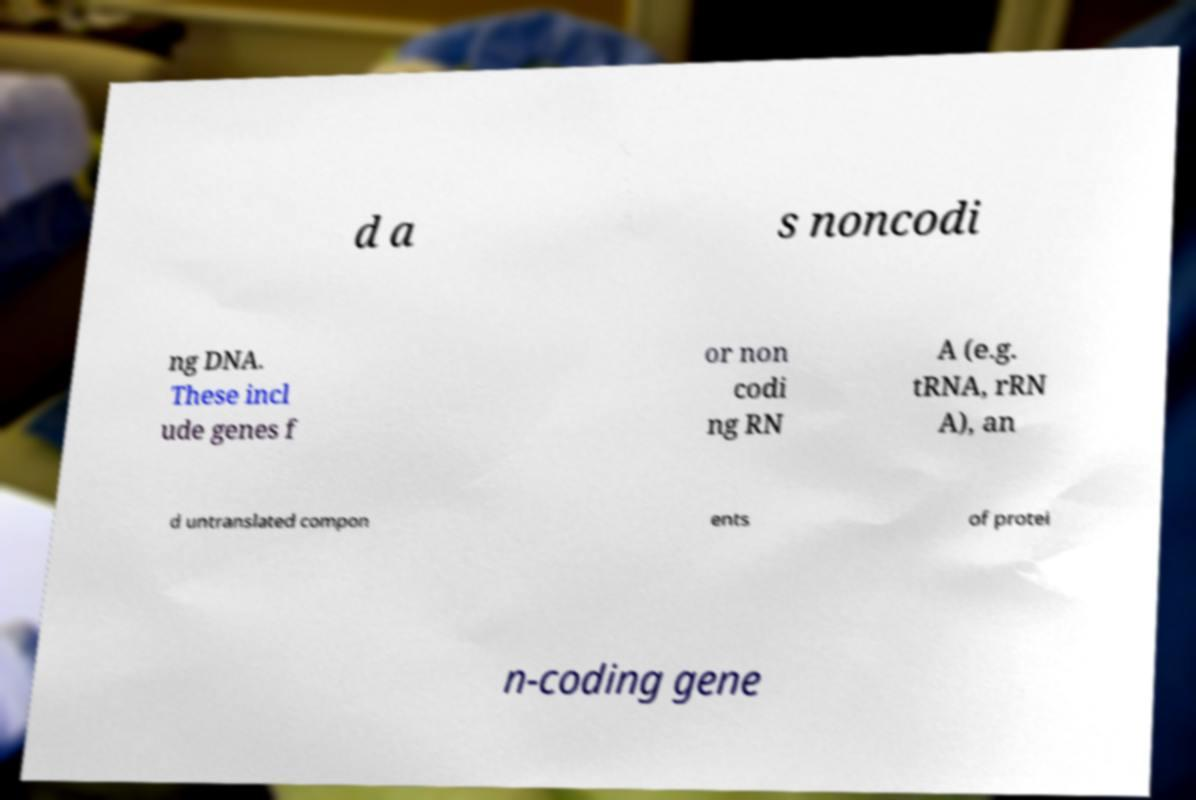Could you extract and type out the text from this image? d a s noncodi ng DNA. These incl ude genes f or non codi ng RN A (e.g. tRNA, rRN A), an d untranslated compon ents of protei n-coding gene 